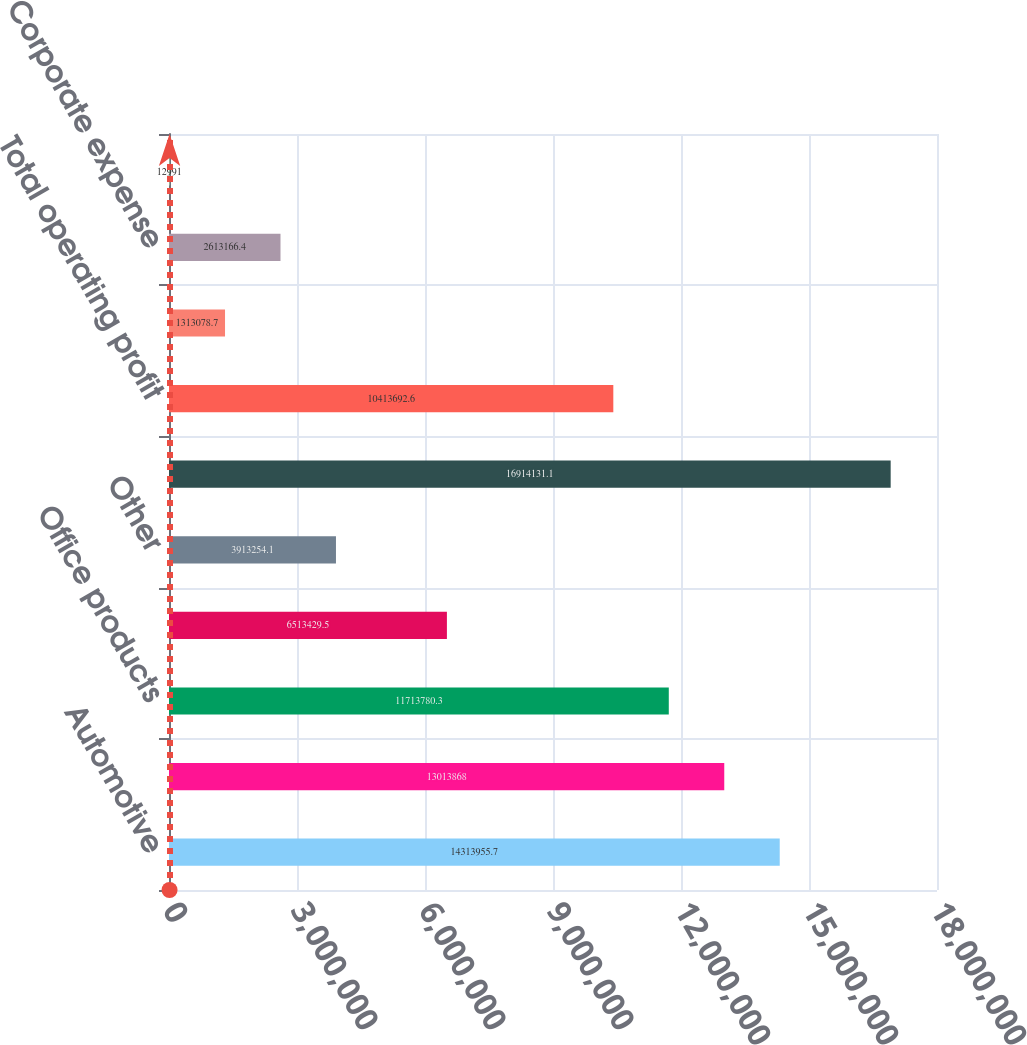<chart> <loc_0><loc_0><loc_500><loc_500><bar_chart><fcel>Automotive<fcel>Industrial<fcel>Office products<fcel>Electrical/electronic<fcel>Other<fcel>Total net sales<fcel>Total operating profit<fcel>Interest expense net<fcel>Corporate expense<fcel>Intangible asset amortization<nl><fcel>1.4314e+07<fcel>1.30139e+07<fcel>1.17138e+07<fcel>6.51343e+06<fcel>3.91325e+06<fcel>1.69141e+07<fcel>1.04137e+07<fcel>1.31308e+06<fcel>2.61317e+06<fcel>12991<nl></chart> 